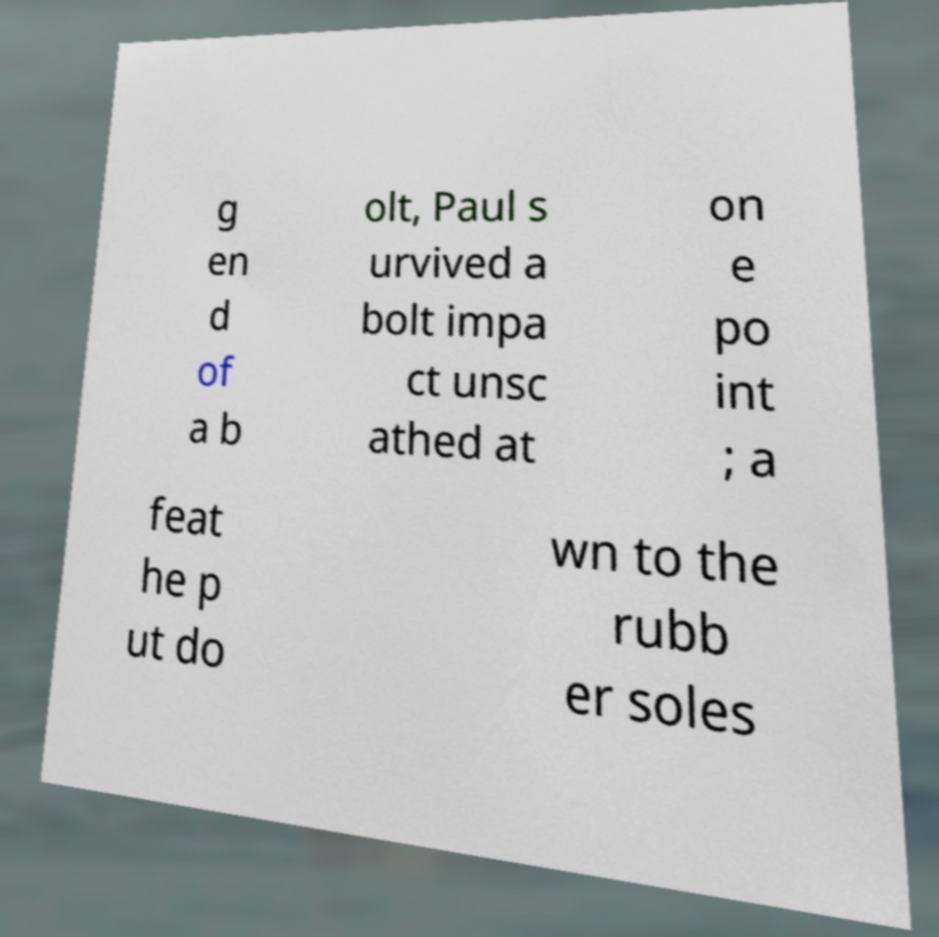What messages or text are displayed in this image? I need them in a readable, typed format. g en d of a b olt, Paul s urvived a bolt impa ct unsc athed at on e po int ; a feat he p ut do wn to the rubb er soles 